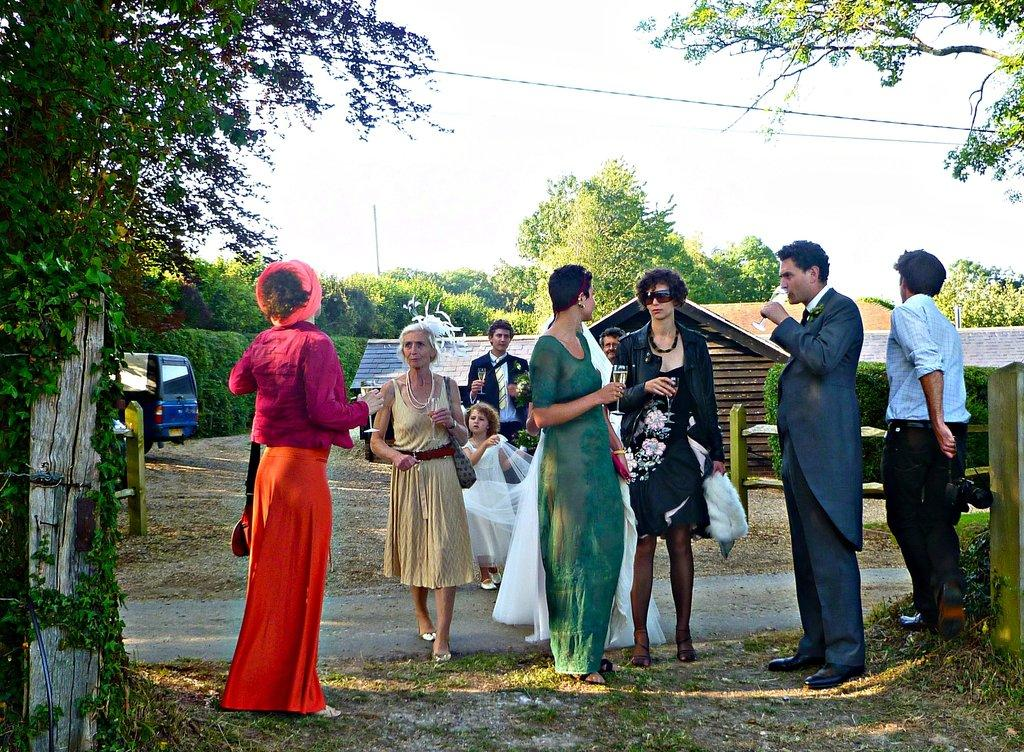How many people are in the image? There is a group of people in the image. What are the people in the image doing? The people are standing. What can be seen in the background of the image? There is a home visible in the background of the image. What type of vegetation is in the image? There are trees in the image. What type of transportation is in the image? There is a vehicle in the image. What else can be seen in the image? There are electrical wires in the image. What color is the guide's shirt in the image? There is no guide present in the image, so it is not possible to determine the color of their shirt. 